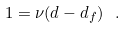<formula> <loc_0><loc_0><loc_500><loc_500>1 = \nu ( d - d _ { f } ) \ .</formula> 